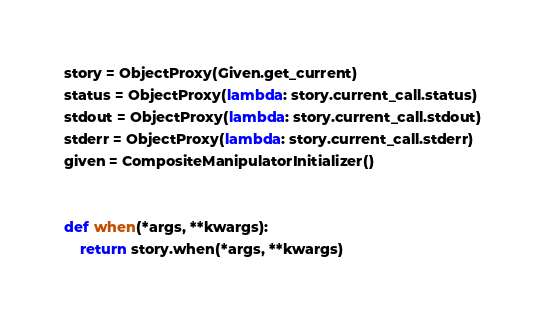<code> <loc_0><loc_0><loc_500><loc_500><_Python_>

story = ObjectProxy(Given.get_current)
status = ObjectProxy(lambda: story.current_call.status)
stdout = ObjectProxy(lambda: story.current_call.stdout)
stderr = ObjectProxy(lambda: story.current_call.stderr)
given = CompositeManipulatorInitializer()


def when(*args, **kwargs):
    return story.when(*args, **kwargs)
</code> 